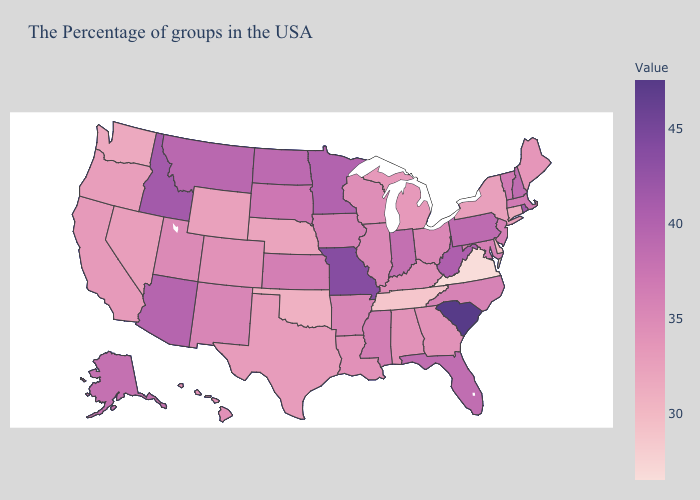Does Maryland have a lower value than Nebraska?
Be succinct. No. Which states hav the highest value in the MidWest?
Keep it brief. Missouri. Does Colorado have a higher value than Oklahoma?
Answer briefly. Yes. Which states have the lowest value in the USA?
Answer briefly. Virginia. Among the states that border Idaho , does Montana have the highest value?
Give a very brief answer. Yes. 